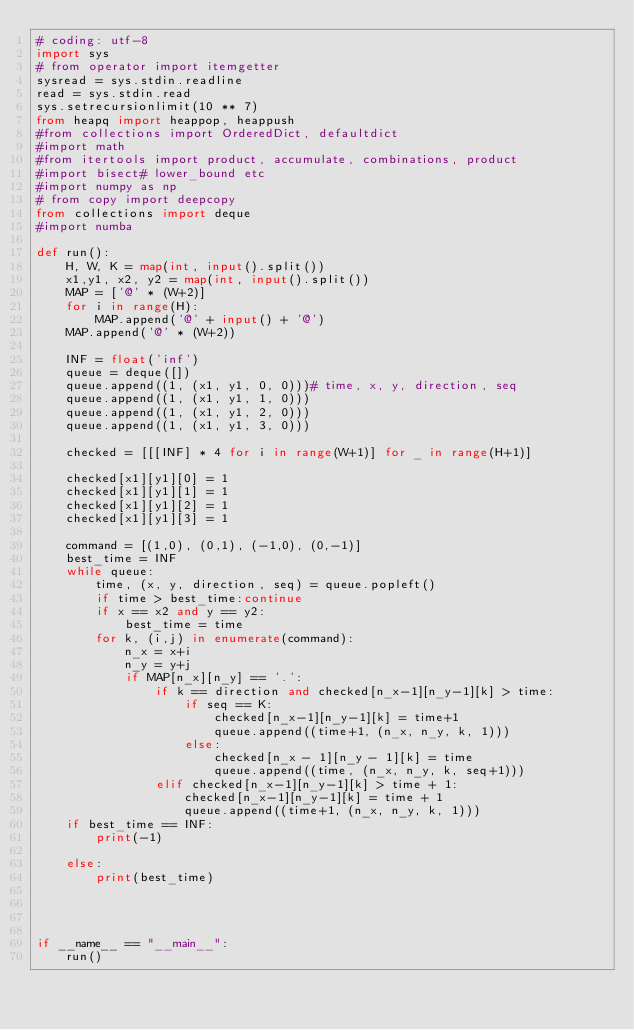Convert code to text. <code><loc_0><loc_0><loc_500><loc_500><_Python_># coding: utf-8
import sys
# from operator import itemgetter
sysread = sys.stdin.readline
read = sys.stdin.read
sys.setrecursionlimit(10 ** 7)
from heapq import heappop, heappush
#from collections import OrderedDict, defaultdict
#import math
#from itertools import product, accumulate, combinations, product
#import bisect# lower_bound etc
#import numpy as np
# from copy import deepcopy
from collections import deque
#import numba

def run():
    H, W, K = map(int, input().split())
    x1,y1, x2, y2 = map(int, input().split())
    MAP = ['@' * (W+2)]
    for i in range(H):
        MAP.append('@' + input() + '@')
    MAP.append('@' * (W+2))

    INF = float('inf')
    queue = deque([])
    queue.append((1, (x1, y1, 0, 0)))# time, x, y, direction, seq
    queue.append((1, (x1, y1, 1, 0)))
    queue.append((1, (x1, y1, 2, 0)))
    queue.append((1, (x1, y1, 3, 0)))

    checked = [[[INF] * 4 for i in range(W+1)] for _ in range(H+1)]

    checked[x1][y1][0] = 1
    checked[x1][y1][1] = 1
    checked[x1][y1][2] = 1
    checked[x1][y1][3] = 1

    command = [(1,0), (0,1), (-1,0), (0,-1)]
    best_time = INF
    while queue:
        time, (x, y, direction, seq) = queue.popleft()
        if time > best_time:continue
        if x == x2 and y == y2:
            best_time = time
        for k, (i,j) in enumerate(command):
            n_x = x+i
            n_y = y+j
            if MAP[n_x][n_y] == '.':
                if k == direction and checked[n_x-1][n_y-1][k] > time:
                    if seq == K:
                        checked[n_x-1][n_y-1][k] = time+1
                        queue.append((time+1, (n_x, n_y, k, 1)))
                    else:
                        checked[n_x - 1][n_y - 1][k] = time
                        queue.append((time, (n_x, n_y, k, seq+1)))
                elif checked[n_x-1][n_y-1][k] > time + 1:
                    checked[n_x-1][n_y-1][k] = time + 1
                    queue.append((time+1, (n_x, n_y, k, 1)))
    if best_time == INF:
        print(-1)

    else:
        print(best_time)




if __name__ == "__main__":
    run()</code> 